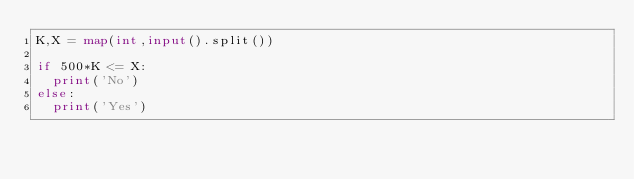<code> <loc_0><loc_0><loc_500><loc_500><_Python_>K,X = map(int,input().split())

if 500*K <= X:
  print('No')
else:
  print('Yes')
</code> 